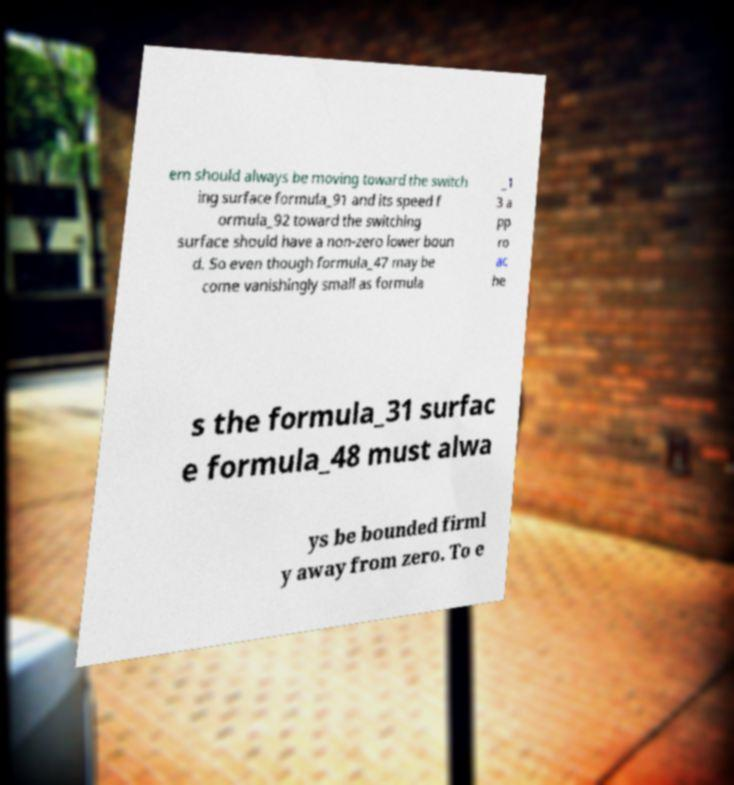Could you extract and type out the text from this image? em should always be moving toward the switch ing surface formula_91 and its speed f ormula_92 toward the switching surface should have a non-zero lower boun d. So even though formula_47 may be come vanishingly small as formula _1 3 a pp ro ac he s the formula_31 surfac e formula_48 must alwa ys be bounded firml y away from zero. To e 